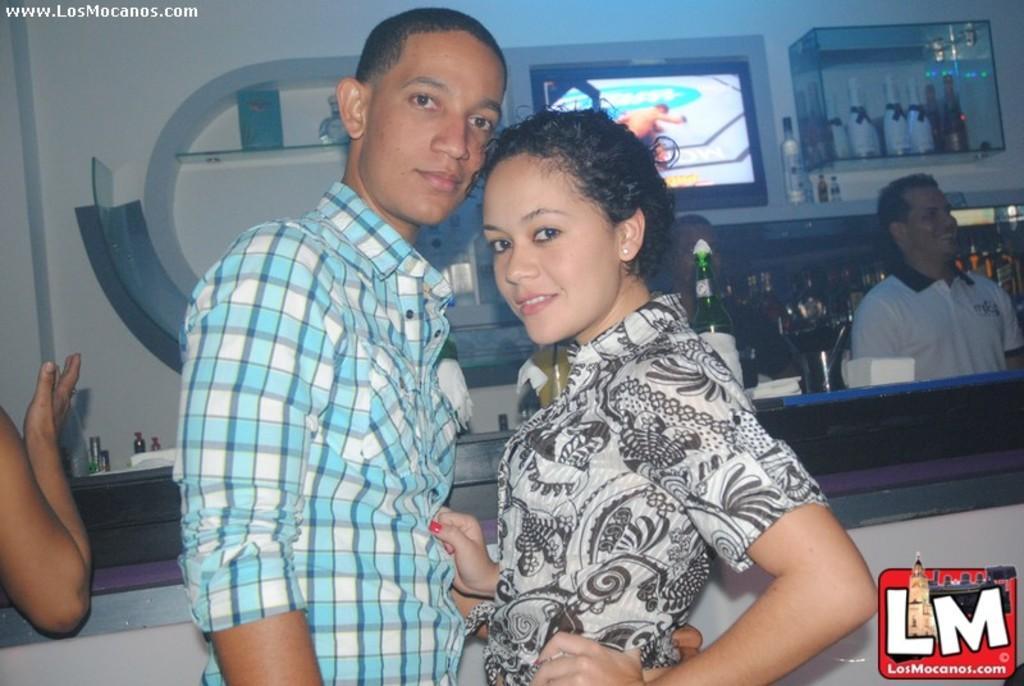How would you summarize this image in a sentence or two? In this image I can see people are standing and I can see smile on few faces. In the background I can see television, number of bottles and here I can see watermark. 